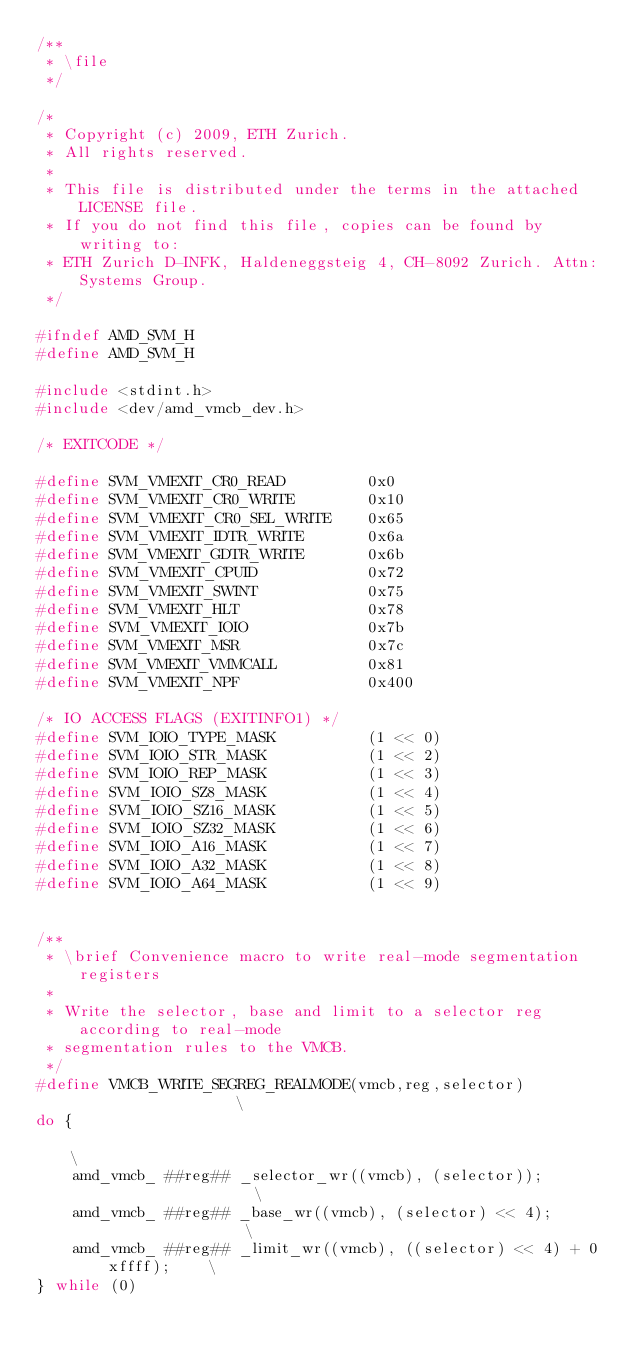Convert code to text. <code><loc_0><loc_0><loc_500><loc_500><_C_>/**
 * \file
 */

/*
 * Copyright (c) 2009, ETH Zurich.
 * All rights reserved.
 *
 * This file is distributed under the terms in the attached LICENSE file.
 * If you do not find this file, copies can be found by writing to:
 * ETH Zurich D-INFK, Haldeneggsteig 4, CH-8092 Zurich. Attn: Systems Group.
 */

#ifndef AMD_SVM_H
#define AMD_SVM_H

#include <stdint.h>
#include <dev/amd_vmcb_dev.h>

/* EXITCODE */

#define SVM_VMEXIT_CR0_READ         0x0
#define SVM_VMEXIT_CR0_WRITE        0x10
#define SVM_VMEXIT_CR0_SEL_WRITE    0x65
#define SVM_VMEXIT_IDTR_WRITE       0x6a
#define SVM_VMEXIT_GDTR_WRITE       0x6b
#define SVM_VMEXIT_CPUID            0x72
#define SVM_VMEXIT_SWINT            0x75
#define SVM_VMEXIT_HLT              0x78
#define SVM_VMEXIT_IOIO             0x7b
#define SVM_VMEXIT_MSR              0x7c
#define SVM_VMEXIT_VMMCALL          0x81
#define SVM_VMEXIT_NPF              0x400

/* IO ACCESS FLAGS (EXITINFO1) */
#define SVM_IOIO_TYPE_MASK          (1 << 0)
#define SVM_IOIO_STR_MASK           (1 << 2)
#define SVM_IOIO_REP_MASK           (1 << 3)
#define SVM_IOIO_SZ8_MASK           (1 << 4)
#define SVM_IOIO_SZ16_MASK          (1 << 5)
#define SVM_IOIO_SZ32_MASK          (1 << 6)
#define SVM_IOIO_A16_MASK           (1 << 7)
#define SVM_IOIO_A32_MASK           (1 << 8)
#define SVM_IOIO_A64_MASK           (1 << 9)


/**
 * \brief Convenience macro to write real-mode segmentation registers
 *
 * Write the selector, base and limit to a selector reg according to real-mode
 * segmentation rules to the VMCB.
 */
#define VMCB_WRITE_SEGREG_REALMODE(vmcb,reg,selector)                   \
do {                                                                    \
    amd_vmcb_ ##reg## _selector_wr((vmcb), (selector));                 \
    amd_vmcb_ ##reg## _base_wr((vmcb), (selector) << 4);                \
    amd_vmcb_ ##reg## _limit_wr((vmcb), ((selector) << 4) + 0xffff);    \
} while (0)
</code> 